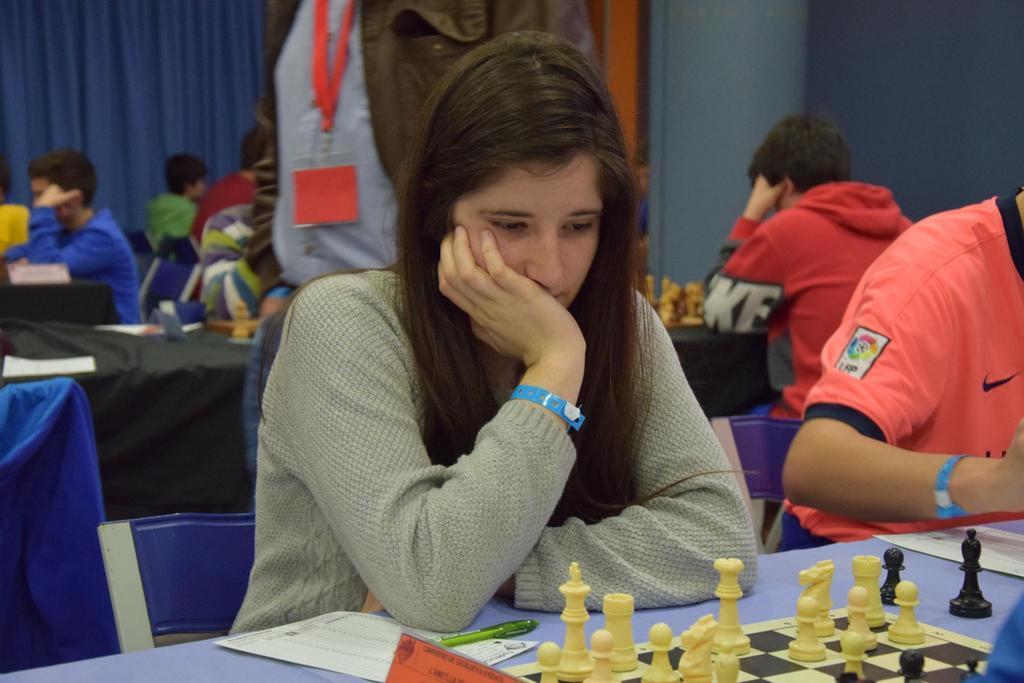Could you give a brief overview of what you see in this image? In this picture I can see few people seated and playing chess and I can see and I can see a human standing he wore a ID card and I can see curtains. 